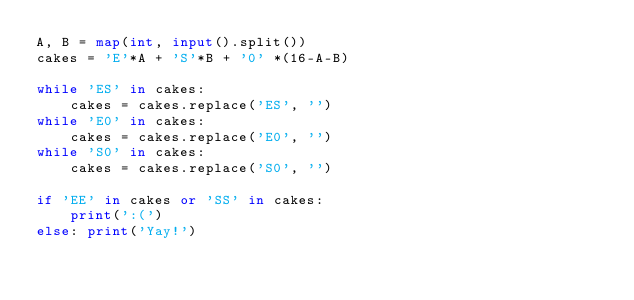Convert code to text. <code><loc_0><loc_0><loc_500><loc_500><_Python_>A, B = map(int, input().split())
cakes = 'E'*A + 'S'*B + '0' *(16-A-B)

while 'ES' in cakes:
    cakes = cakes.replace('ES', '')
while 'E0' in cakes:
    cakes = cakes.replace('E0', '')
while 'S0' in cakes:
    cakes = cakes.replace('S0', '')

if 'EE' in cakes or 'SS' in cakes:
    print(':(')
else: print('Yay!')
</code> 